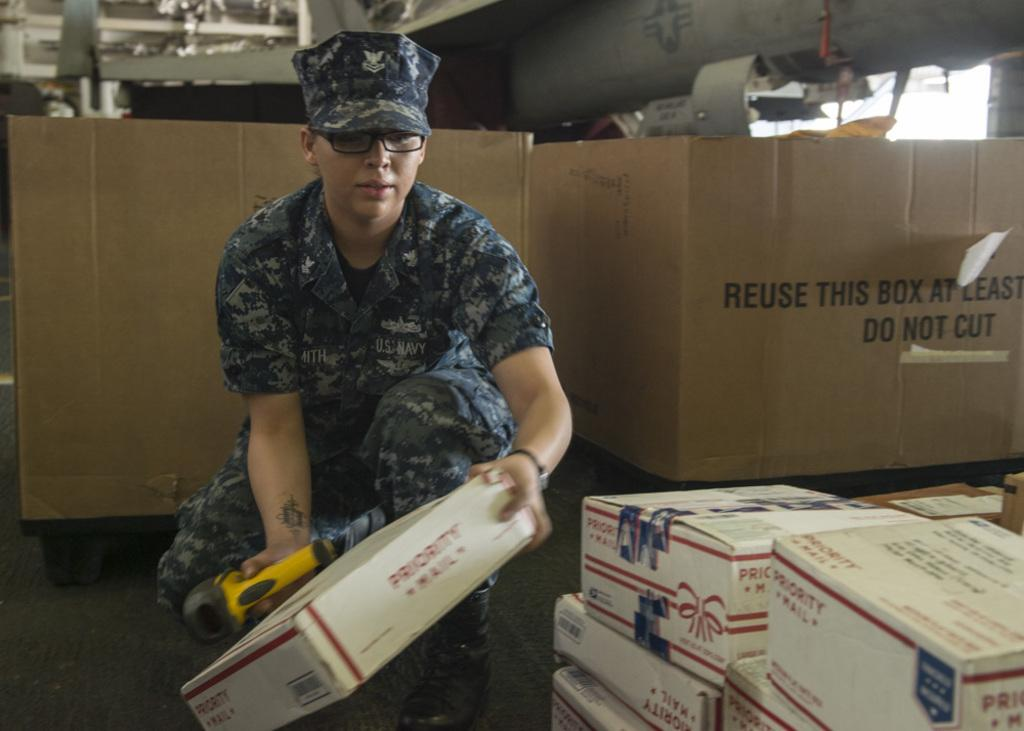Provide a one-sentence caption for the provided image. A person holding onto a priority mail box. 